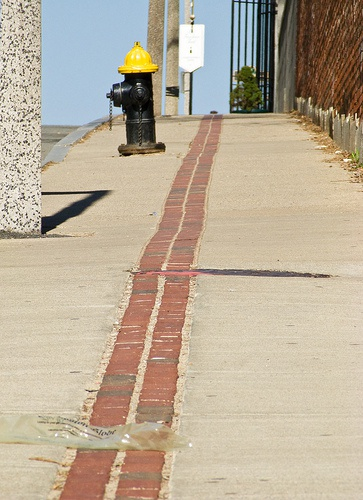Describe the objects in this image and their specific colors. I can see a fire hydrant in lightblue, black, gold, olive, and gray tones in this image. 